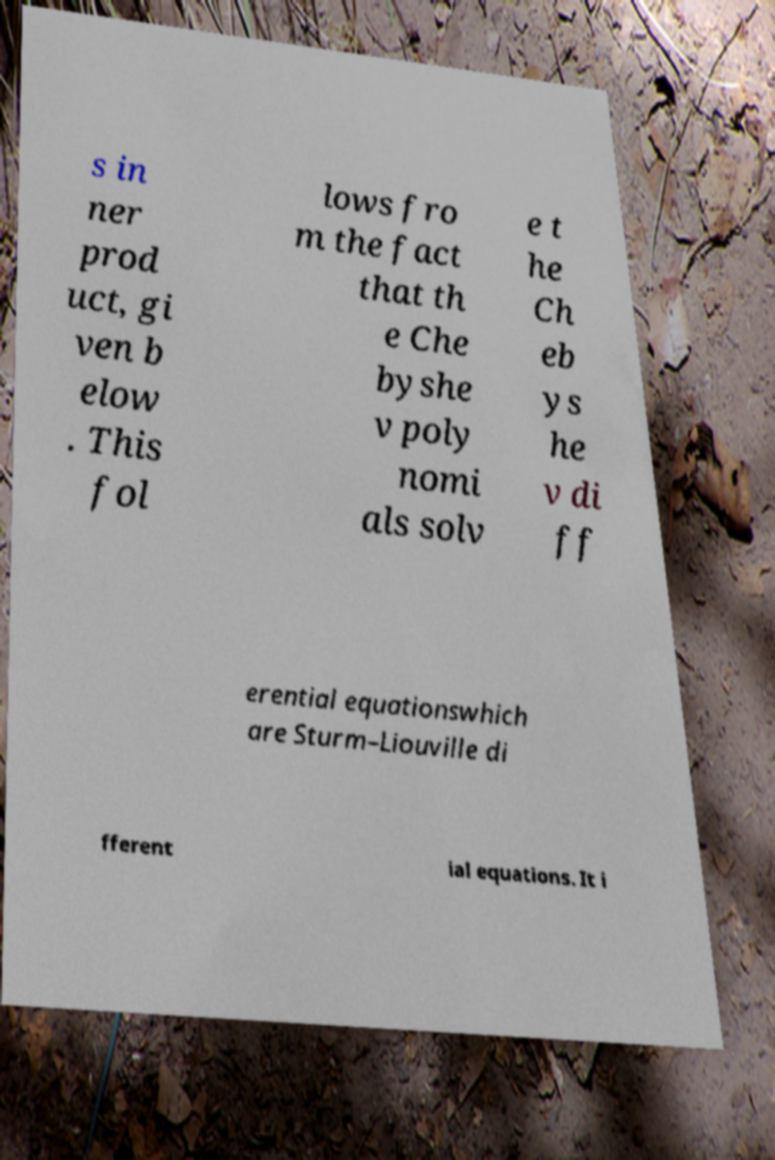I need the written content from this picture converted into text. Can you do that? s in ner prod uct, gi ven b elow . This fol lows fro m the fact that th e Che byshe v poly nomi als solv e t he Ch eb ys he v di ff erential equationswhich are Sturm–Liouville di fferent ial equations. It i 